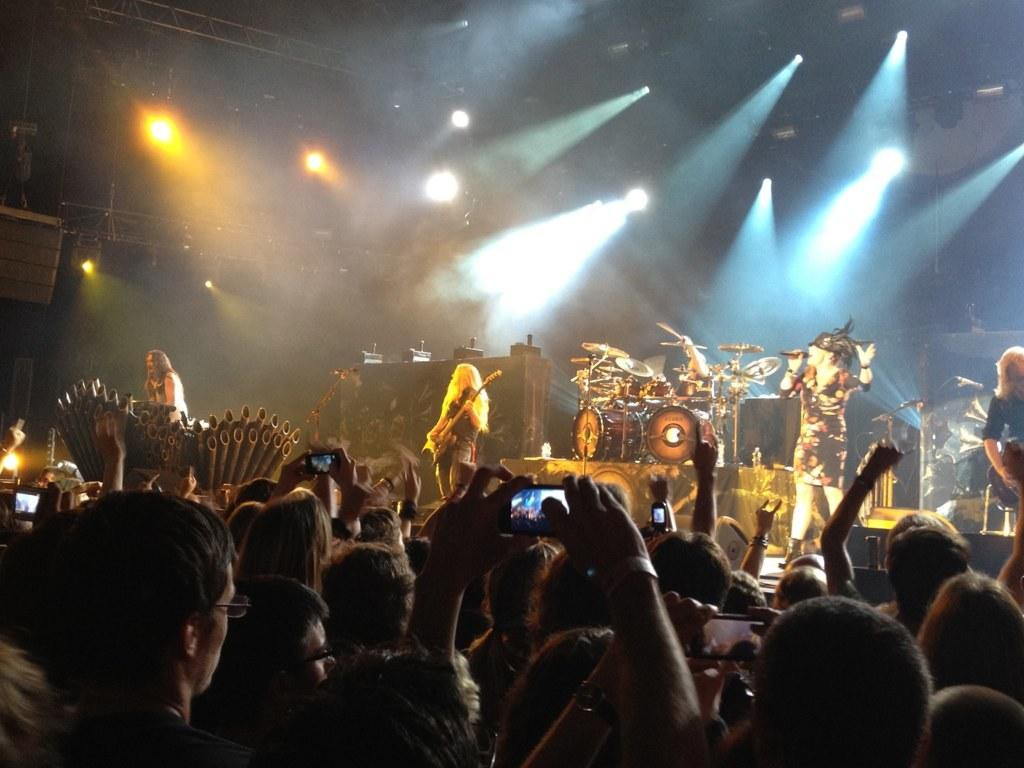What are the people in the image doing? The people in the image are singing and playing music instruments on stage. What can be seen above the stage in the image? There are many lights on the ceiling in the image. Who is present in front of the stage? There is an audience in front of the stage. What are the audience members doing during the performance? The audience members are capturing the performance on their phones. Can you tell me how many legs the fish in the image has? There is no fish present in the image, so it is not possible to determine the number of legs it might have. 